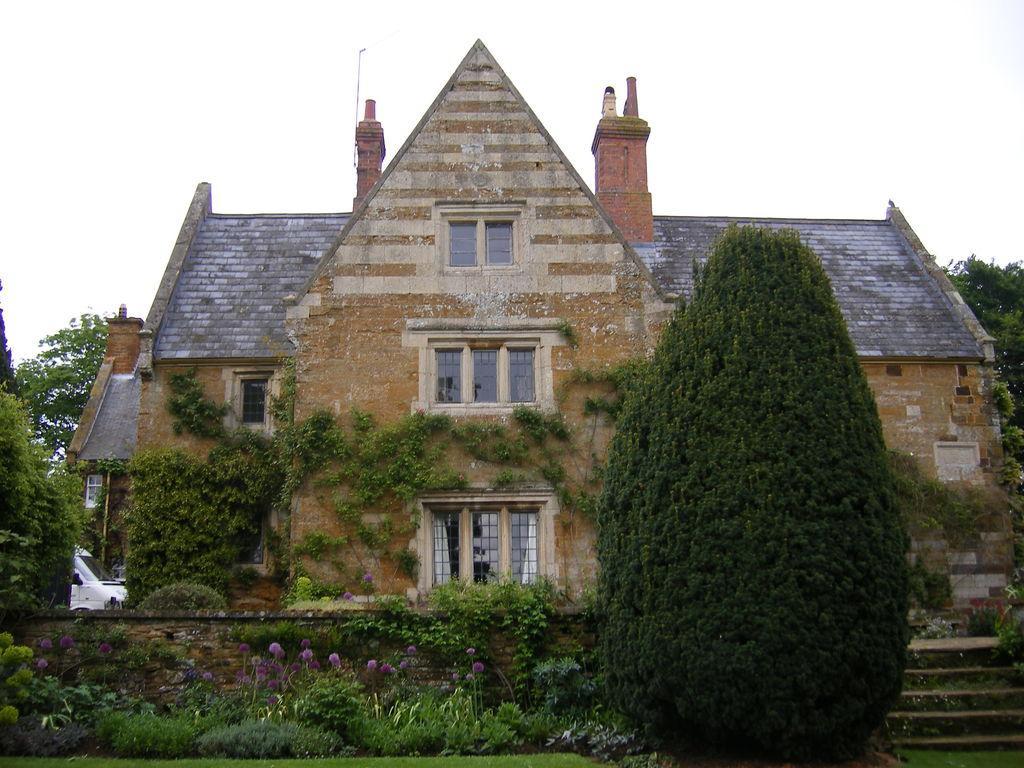Can you describe this image briefly? In the center of the image we can see building, windows, wall, pole, vehicle, bushes, flowers, stairs. At the bottom of the image there is a grass. At the top of the image there is a sky. In the middle of the image trees are there. 